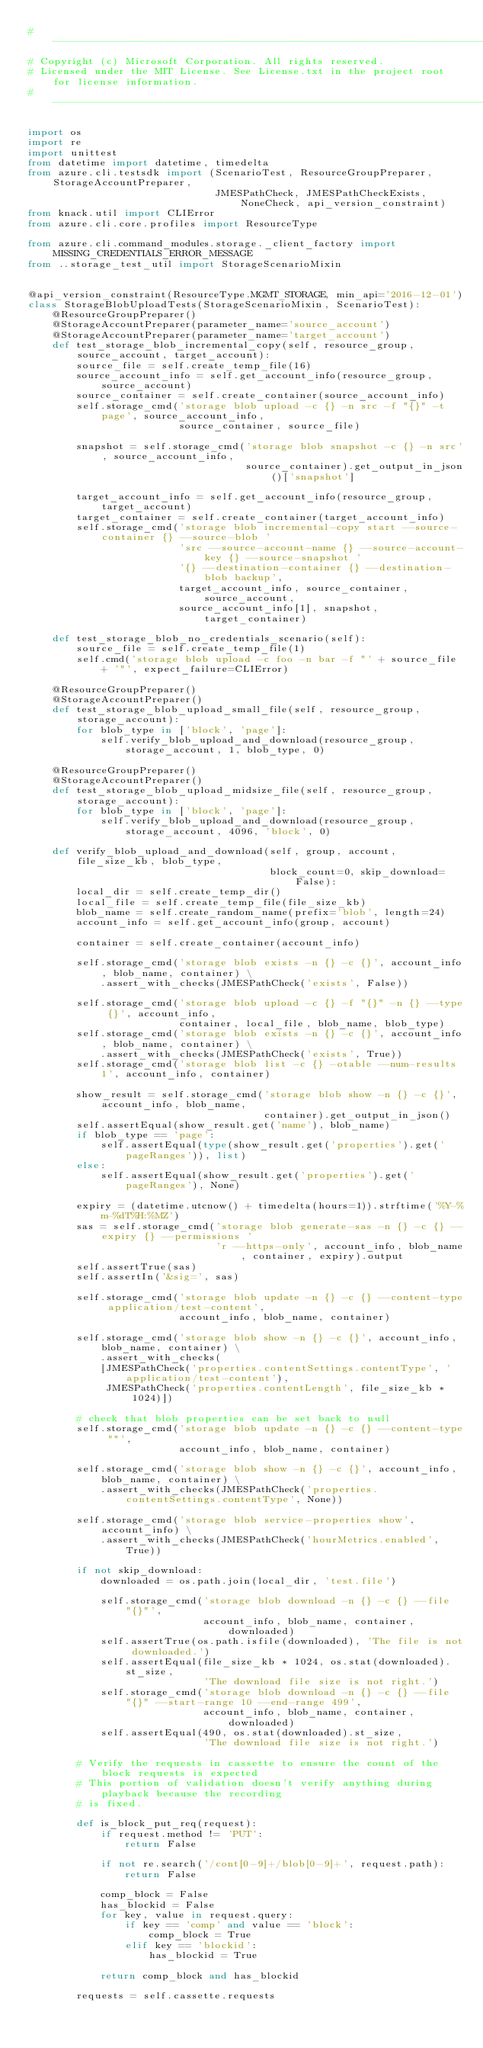Convert code to text. <code><loc_0><loc_0><loc_500><loc_500><_Python_># --------------------------------------------------------------------------------------------
# Copyright (c) Microsoft Corporation. All rights reserved.
# Licensed under the MIT License. See License.txt in the project root for license information.
# --------------------------------------------------------------------------------------------

import os
import re
import unittest
from datetime import datetime, timedelta
from azure.cli.testsdk import (ScenarioTest, ResourceGroupPreparer, StorageAccountPreparer,
                               JMESPathCheck, JMESPathCheckExists, NoneCheck, api_version_constraint)
from knack.util import CLIError
from azure.cli.core.profiles import ResourceType

from azure.cli.command_modules.storage._client_factory import MISSING_CREDENTIALS_ERROR_MESSAGE
from ..storage_test_util import StorageScenarioMixin


@api_version_constraint(ResourceType.MGMT_STORAGE, min_api='2016-12-01')
class StorageBlobUploadTests(StorageScenarioMixin, ScenarioTest):
    @ResourceGroupPreparer()
    @StorageAccountPreparer(parameter_name='source_account')
    @StorageAccountPreparer(parameter_name='target_account')
    def test_storage_blob_incremental_copy(self, resource_group, source_account, target_account):
        source_file = self.create_temp_file(16)
        source_account_info = self.get_account_info(resource_group, source_account)
        source_container = self.create_container(source_account_info)
        self.storage_cmd('storage blob upload -c {} -n src -f "{}" -t page', source_account_info,
                         source_container, source_file)

        snapshot = self.storage_cmd('storage blob snapshot -c {} -n src', source_account_info,
                                    source_container).get_output_in_json()['snapshot']

        target_account_info = self.get_account_info(resource_group, target_account)
        target_container = self.create_container(target_account_info)
        self.storage_cmd('storage blob incremental-copy start --source-container {} --source-blob '
                         'src --source-account-name {} --source-account-key {} --source-snapshot '
                         '{} --destination-container {} --destination-blob backup',
                         target_account_info, source_container, source_account,
                         source_account_info[1], snapshot, target_container)

    def test_storage_blob_no_credentials_scenario(self):
        source_file = self.create_temp_file(1)
        self.cmd('storage blob upload -c foo -n bar -f "' + source_file + '"', expect_failure=CLIError)

    @ResourceGroupPreparer()
    @StorageAccountPreparer()
    def test_storage_blob_upload_small_file(self, resource_group, storage_account):
        for blob_type in ['block', 'page']:
            self.verify_blob_upload_and_download(resource_group, storage_account, 1, blob_type, 0)

    @ResourceGroupPreparer()
    @StorageAccountPreparer()
    def test_storage_blob_upload_midsize_file(self, resource_group, storage_account):
        for blob_type in ['block', 'page']:
            self.verify_blob_upload_and_download(resource_group, storage_account, 4096, 'block', 0)

    def verify_blob_upload_and_download(self, group, account, file_size_kb, blob_type,
                                        block_count=0, skip_download=False):
        local_dir = self.create_temp_dir()
        local_file = self.create_temp_file(file_size_kb)
        blob_name = self.create_random_name(prefix='blob', length=24)
        account_info = self.get_account_info(group, account)

        container = self.create_container(account_info)

        self.storage_cmd('storage blob exists -n {} -c {}', account_info, blob_name, container) \
            .assert_with_checks(JMESPathCheck('exists', False))

        self.storage_cmd('storage blob upload -c {} -f "{}" -n {} --type {}', account_info,
                         container, local_file, blob_name, blob_type)
        self.storage_cmd('storage blob exists -n {} -c {}', account_info, blob_name, container) \
            .assert_with_checks(JMESPathCheck('exists', True))
        self.storage_cmd('storage blob list -c {} -otable --num-results 1', account_info, container)

        show_result = self.storage_cmd('storage blob show -n {} -c {}', account_info, blob_name,
                                       container).get_output_in_json()
        self.assertEqual(show_result.get('name'), blob_name)
        if blob_type == 'page':
            self.assertEqual(type(show_result.get('properties').get('pageRanges')), list)
        else:
            self.assertEqual(show_result.get('properties').get('pageRanges'), None)

        expiry = (datetime.utcnow() + timedelta(hours=1)).strftime('%Y-%m-%dT%H:%MZ')
        sas = self.storage_cmd('storage blob generate-sas -n {} -c {} --expiry {} --permissions '
                               'r --https-only', account_info, blob_name, container, expiry).output
        self.assertTrue(sas)
        self.assertIn('&sig=', sas)

        self.storage_cmd('storage blob update -n {} -c {} --content-type application/test-content',
                         account_info, blob_name, container)

        self.storage_cmd('storage blob show -n {} -c {}', account_info, blob_name, container) \
            .assert_with_checks(
            [JMESPathCheck('properties.contentSettings.contentType', 'application/test-content'),
             JMESPathCheck('properties.contentLength', file_size_kb * 1024)])

        # check that blob properties can be set back to null
        self.storage_cmd('storage blob update -n {} -c {} --content-type ""',
                         account_info, blob_name, container)

        self.storage_cmd('storage blob show -n {} -c {}', account_info, blob_name, container) \
            .assert_with_checks(JMESPathCheck('properties.contentSettings.contentType', None))

        self.storage_cmd('storage blob service-properties show', account_info) \
            .assert_with_checks(JMESPathCheck('hourMetrics.enabled', True))

        if not skip_download:
            downloaded = os.path.join(local_dir, 'test.file')

            self.storage_cmd('storage blob download -n {} -c {} --file "{}"',
                             account_info, blob_name, container, downloaded)
            self.assertTrue(os.path.isfile(downloaded), 'The file is not downloaded.')
            self.assertEqual(file_size_kb * 1024, os.stat(downloaded).st_size,
                             'The download file size is not right.')
            self.storage_cmd('storage blob download -n {} -c {} --file "{}" --start-range 10 --end-range 499',
                             account_info, blob_name, container, downloaded)
            self.assertEqual(490, os.stat(downloaded).st_size,
                             'The download file size is not right.')

        # Verify the requests in cassette to ensure the count of the block requests is expected
        # This portion of validation doesn't verify anything during playback because the recording
        # is fixed.

        def is_block_put_req(request):
            if request.method != 'PUT':
                return False

            if not re.search('/cont[0-9]+/blob[0-9]+', request.path):
                return False

            comp_block = False
            has_blockid = False
            for key, value in request.query:
                if key == 'comp' and value == 'block':
                    comp_block = True
                elif key == 'blockid':
                    has_blockid = True

            return comp_block and has_blockid

        requests = self.cassette.requests</code> 